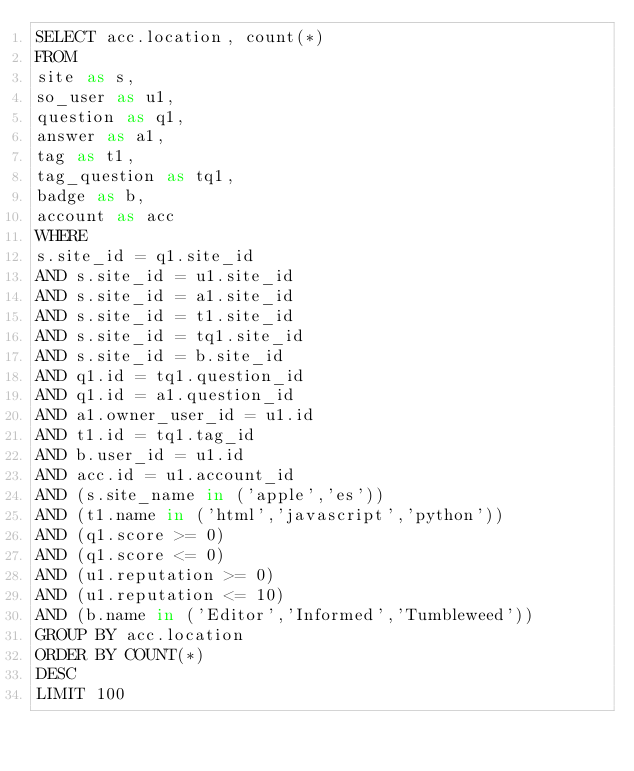Convert code to text. <code><loc_0><loc_0><loc_500><loc_500><_SQL_>SELECT acc.location, count(*)
FROM
site as s,
so_user as u1,
question as q1,
answer as a1,
tag as t1,
tag_question as tq1,
badge as b,
account as acc
WHERE
s.site_id = q1.site_id
AND s.site_id = u1.site_id
AND s.site_id = a1.site_id
AND s.site_id = t1.site_id
AND s.site_id = tq1.site_id
AND s.site_id = b.site_id
AND q1.id = tq1.question_id
AND q1.id = a1.question_id
AND a1.owner_user_id = u1.id
AND t1.id = tq1.tag_id
AND b.user_id = u1.id
AND acc.id = u1.account_id
AND (s.site_name in ('apple','es'))
AND (t1.name in ('html','javascript','python'))
AND (q1.score >= 0)
AND (q1.score <= 0)
AND (u1.reputation >= 0)
AND (u1.reputation <= 10)
AND (b.name in ('Editor','Informed','Tumbleweed'))
GROUP BY acc.location
ORDER BY COUNT(*)
DESC
LIMIT 100
</code> 